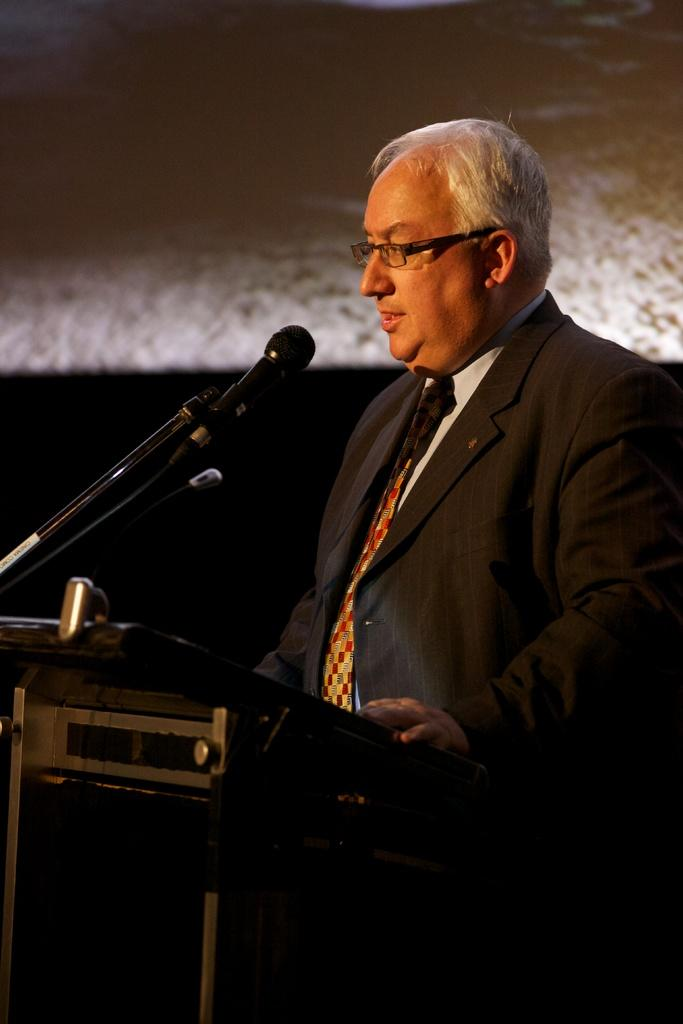Who is the main subject in the foreground of the image? There is a man in the foreground of the image. What is the man wearing? The man is wearing a suit. What object is in front of the man? There is a podium in front of the man. What device is present in front of the man for amplifying his voice? A microphone is present in front of the man. What can be seen in the background of the image? There is a wall in the background of the image. What is the tendency of the sheet in the image? There is no sheet present in the image, so it is not possible to determine its tendency. 